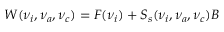Convert formula to latex. <formula><loc_0><loc_0><loc_500><loc_500>W ( \nu _ { i } , \nu _ { a } , \nu _ { c } ) = F ( \nu _ { i } ) + S _ { s } ( \nu _ { i } , \nu _ { a } , \nu _ { c } ) B</formula> 